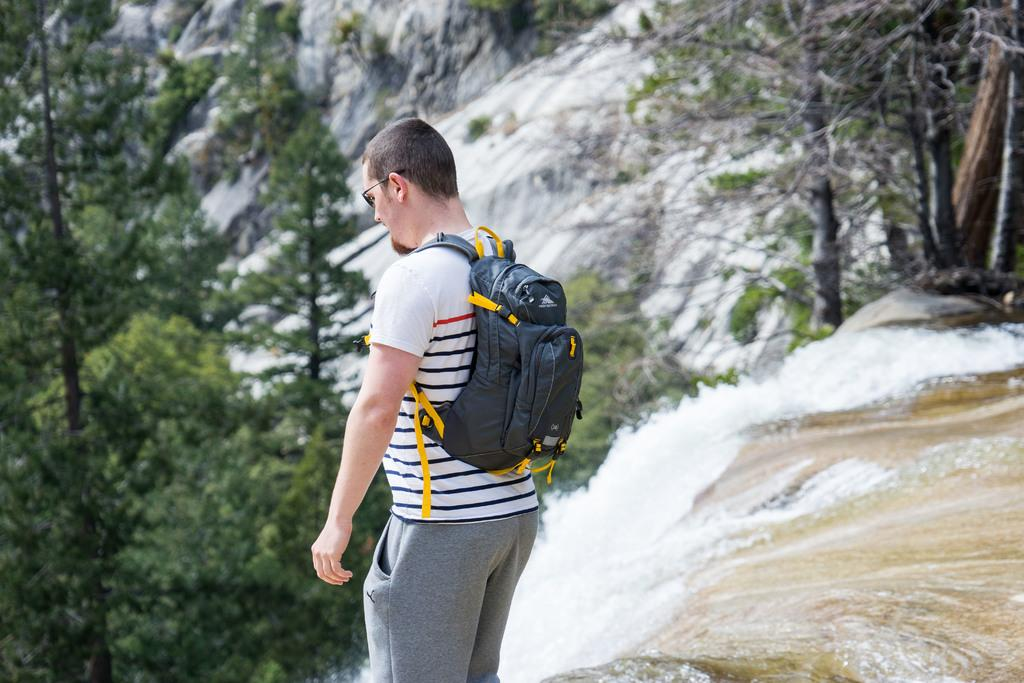Who is the person in the image? There is a man in the image. What is the man wearing? The man is wearing a white t-shirt. What is the man carrying in the image? The man is carrying a backpack. What can be seen in the background of the image? There is water and trees visible in the background of the image. What type of cart is the man pushing in the image? There is no cart present in the image; the man is carrying a backpack. 